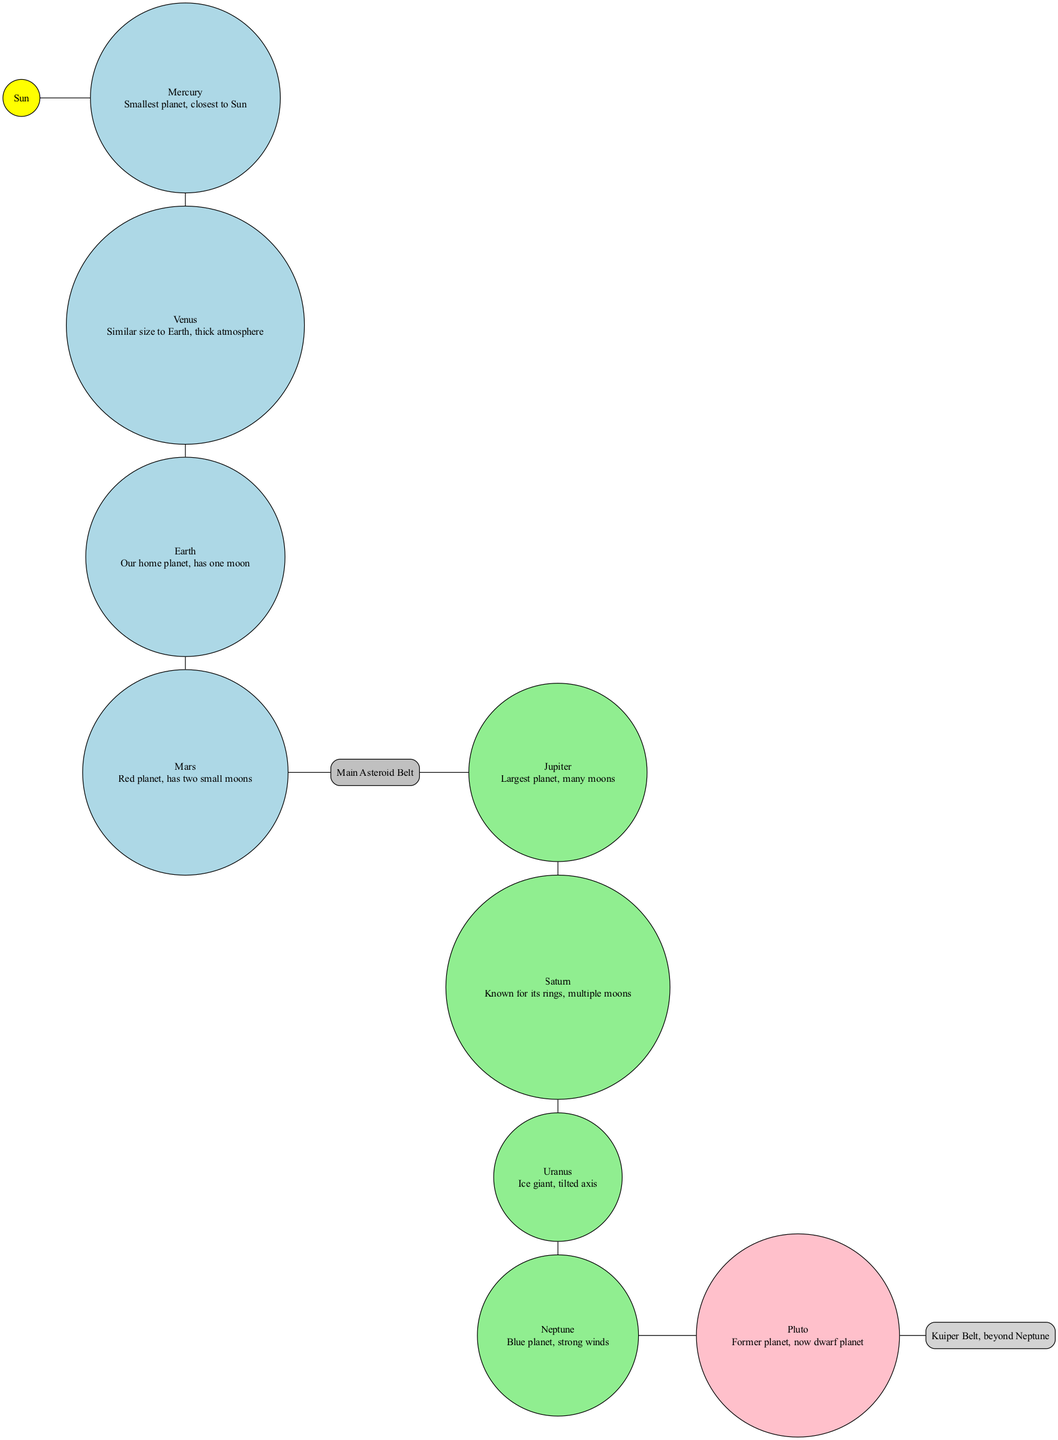What is the largest planet in our solar system? The diagram clearly indicates that Jupiter is labeled as the largest planet among the outer planets, and there is no other planet larger than it in the diagram.
Answer: Jupiter How many moons does Earth have? The diagram states that Earth has one moon mentioned in its description, which can be easily noted when reading the node for Earth.
Answer: One What comes after Mars in the inner planets? According to the diagram's flow from the inner planets, the last inner planet mentioned is Mars, and the next node connected after Mars is the Main Asteroid Belt.
Answer: Main Asteroid Belt What color is the Sun represented in the diagram? The diagram depicts the Sun using a yellow fill color, which is specified in the properties of the node for the Sun.
Answer: Yellow Which planet is known for its rings? In the diagram, Saturn is described as being known for its rings, which can be directly read from its node description.
Answer: Saturn How many inner planets are there? The diagram lists four inner planets: Mercury, Venus, Earth, and Mars. By counting the nodes included in the inner planet category, we find the total is four.
Answer: Four What is the relationship between the asteroid belt and the outer planets? The diagram shows a direct edge connecting the Main Asteroid Belt to Jupiter, indicating that the outer planets follow the asteroid belt in the solar system layout.
Answer: Outer planets follow after the asteroid belt What is the description of the dwarf planet? The dwarf planet node clearly states that it is "Former planet, now dwarf planet," which is evident from the text inside its designated node.
Answer: Former planet, now dwarf planet Which celestial structure is located beyond Neptune? The diagram indicates that the Kuiper Belt is specifically labeled as the structure that exists beyond Neptune, denoted in the appropriate section of the layout.
Answer: Kuiper Belt 